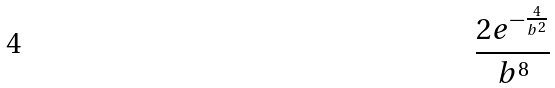<formula> <loc_0><loc_0><loc_500><loc_500>\frac { 2 e ^ { - \frac { 4 } { b ^ { 2 } } } } { b ^ { 8 } }</formula> 